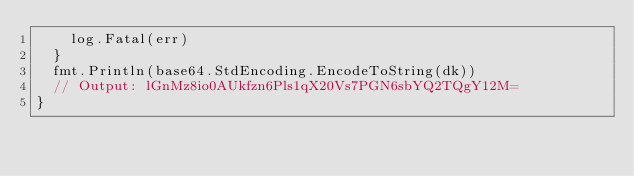Convert code to text. <code><loc_0><loc_0><loc_500><loc_500><_Go_>		log.Fatal(err)
	}
	fmt.Println(base64.StdEncoding.EncodeToString(dk))
	// Output: lGnMz8io0AUkfzn6Pls1qX20Vs7PGN6sbYQ2TQgY12M=
}
</code> 